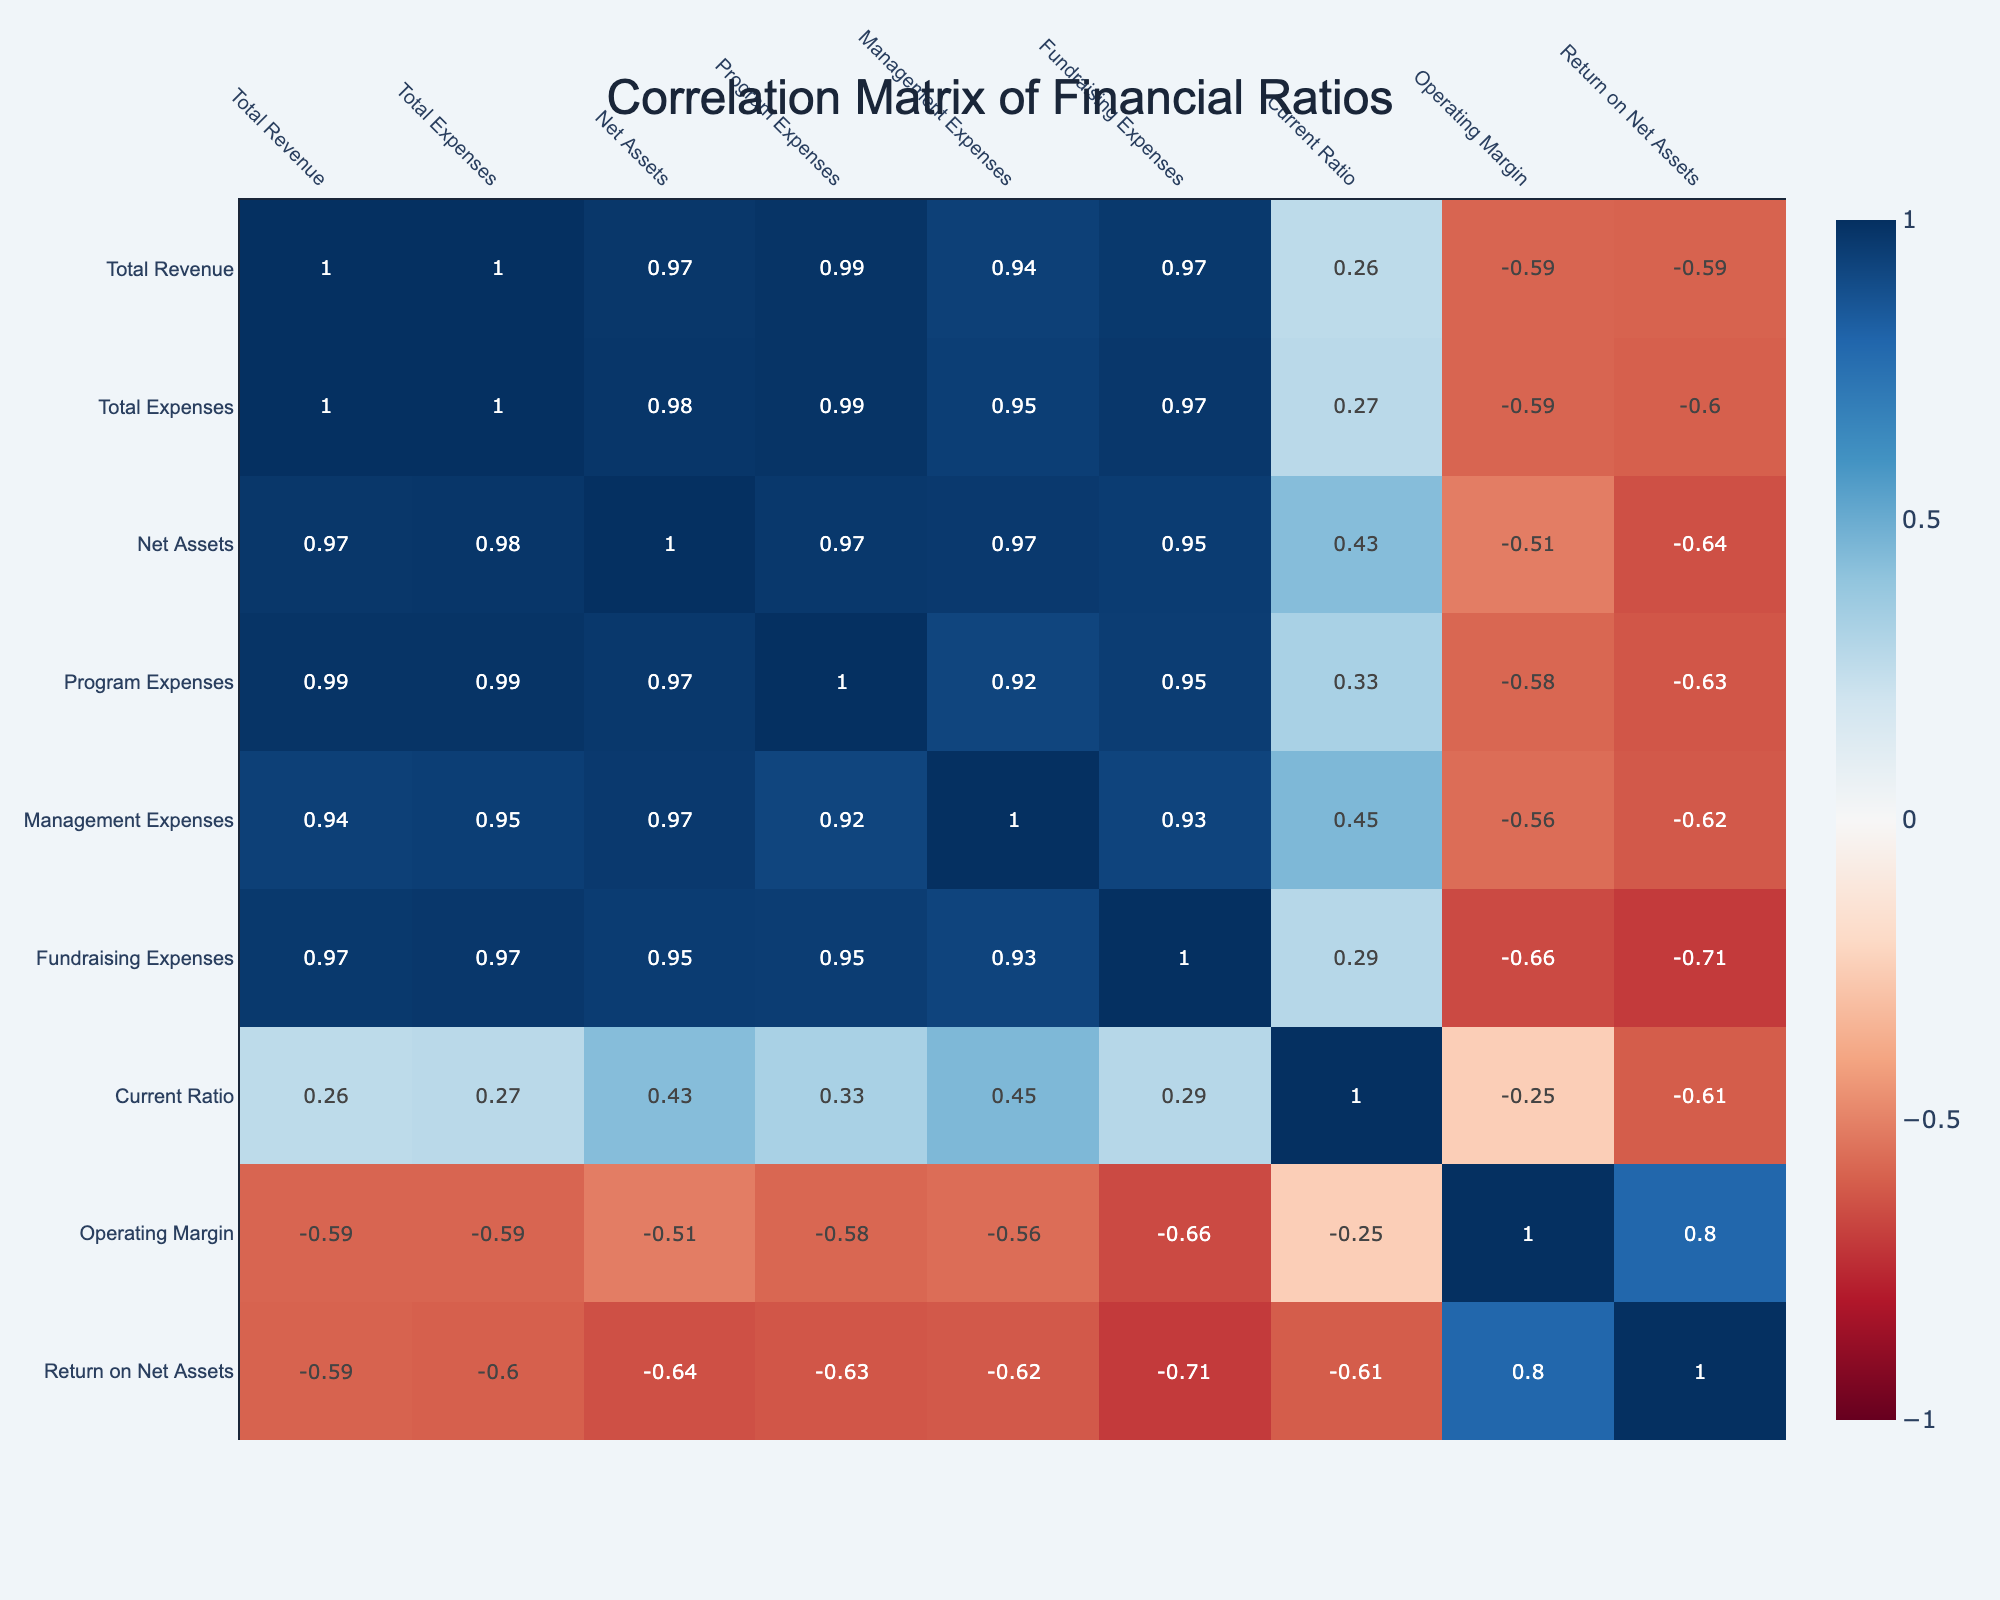What is the total revenue for Habitat for Humanity? The table shows that the Total Revenue for Habitat for Humanity is listed as 150,000,000.
Answer: 150000000 Which organization has the highest operating margin? To find this, we look at the Operating Margin values from each organization. The organization with the highest value is Catholic Relief Services at 0.11.
Answer: Catholic Relief Services What is the difference between the total expenses of St. Jude Children's Research Hospital and Feeding America? The total expenses for St. Jude Children's Research Hospital are 450,000,000 and for Feeding America they are 270,000,000. The difference is calculated as 450,000,000 - 270,000,000 = 180,000,000.
Answer: 180000000 Does Save the Children have a higher current ratio than World Wildlife Fund? The current ratio for Save the Children is 1.35, while for World Wildlife Fund it is 1.20. Since 1.35 is greater than 1.20, the statement is true.
Answer: Yes What is the average return on net assets (RONA) for the organizations listed? To find the average RONA, we sum the return values: (0.08 + 0.06 + 0.10 + 0.05 + 0.07 + 0.06 + 0.04) and divide by the number of organizations (7). The average is (0.46 / 7) = 0.0657, rounded to 0.07.
Answer: 0.07 Which organization has the lowest total assets according to the data? To determine this, we compare the Net Assets values across the organizations. St. Jude Children's Research Hospital has the lowest net assets at 100,000,000.
Answer: St. Jude Children's Research Hospital Is the total revenue of Boys & Girls Clubs of America more than that of Catholic Relief Services? The total revenue for Boys & Girls Clubs of America is 120,000,000, while for Catholic Relief Services it is 95,000,000. This means Boys & Girls Clubs of America has a higher total revenue, making the statement true.
Answer: Yes By how much do the management expenses of Habitat for Humanity exceed those of World Wildlife Fund? Habitat for Humanity has management expenses of 20,000,000, while World Wildlife Fund has 25,000,000. The difference is 20,000,000 - 25,000,000 = -5,000,000, indicating that World Wildlife Fund has higher expenses by 5,000,000.
Answer: 5000000 